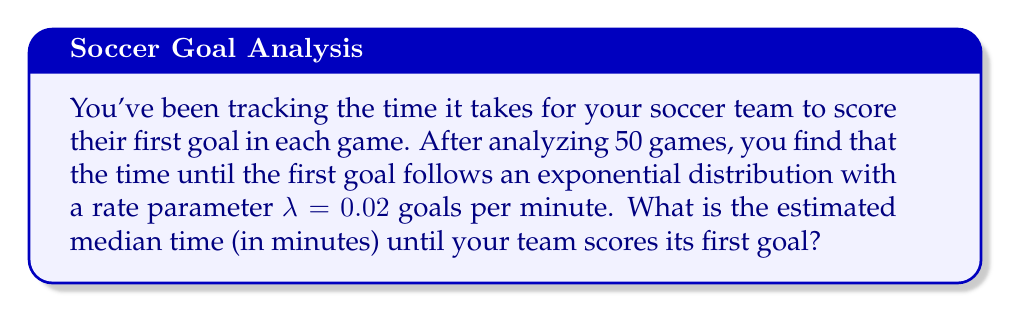What is the answer to this math problem? To solve this problem, we'll use survival analysis techniques, specifically for an exponential distribution:

1) The survival function for an exponential distribution is:
   $S(t) = e^{-\lambda t}$

2) The median time is when the survival probability is 0.5, so we need to solve:
   $S(t) = 0.5$

3) Substituting the survival function:
   $e^{-\lambda t} = 0.5$

4) Taking the natural log of both sides:
   $-\lambda t = \ln(0.5)$

5) Solving for t:
   $t = -\frac{\ln(0.5)}{\lambda}$

6) We're given $\lambda = 0.02$, so let's substitute:
   $t = -\frac{\ln(0.5)}{0.02}$

7) Calculating:
   $t \approx 34.66$ minutes

Therefore, the estimated median time until the team scores its first goal is approximately 34.66 minutes.
Answer: 34.66 minutes 